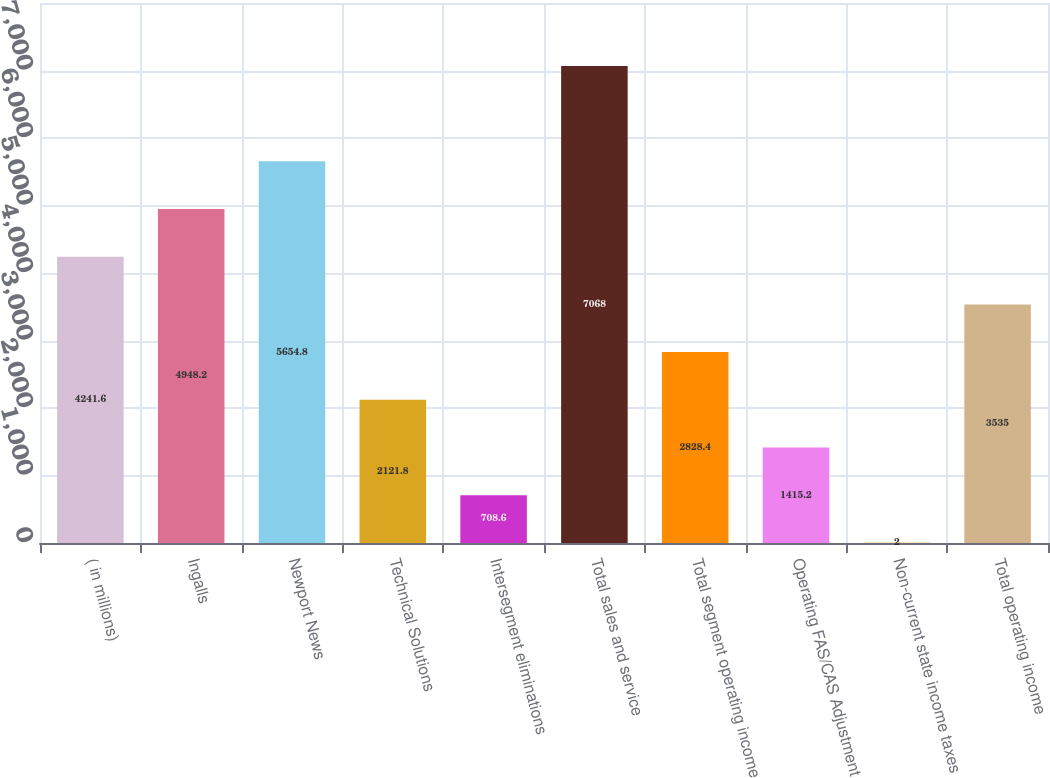<chart> <loc_0><loc_0><loc_500><loc_500><bar_chart><fcel>( in millions)<fcel>Ingalls<fcel>Newport News<fcel>Technical Solutions<fcel>Intersegment eliminations<fcel>Total sales and service<fcel>Total segment operating income<fcel>Operating FAS/CAS Adjustment<fcel>Non-current state income taxes<fcel>Total operating income<nl><fcel>4241.6<fcel>4948.2<fcel>5654.8<fcel>2121.8<fcel>708.6<fcel>7068<fcel>2828.4<fcel>1415.2<fcel>2<fcel>3535<nl></chart> 